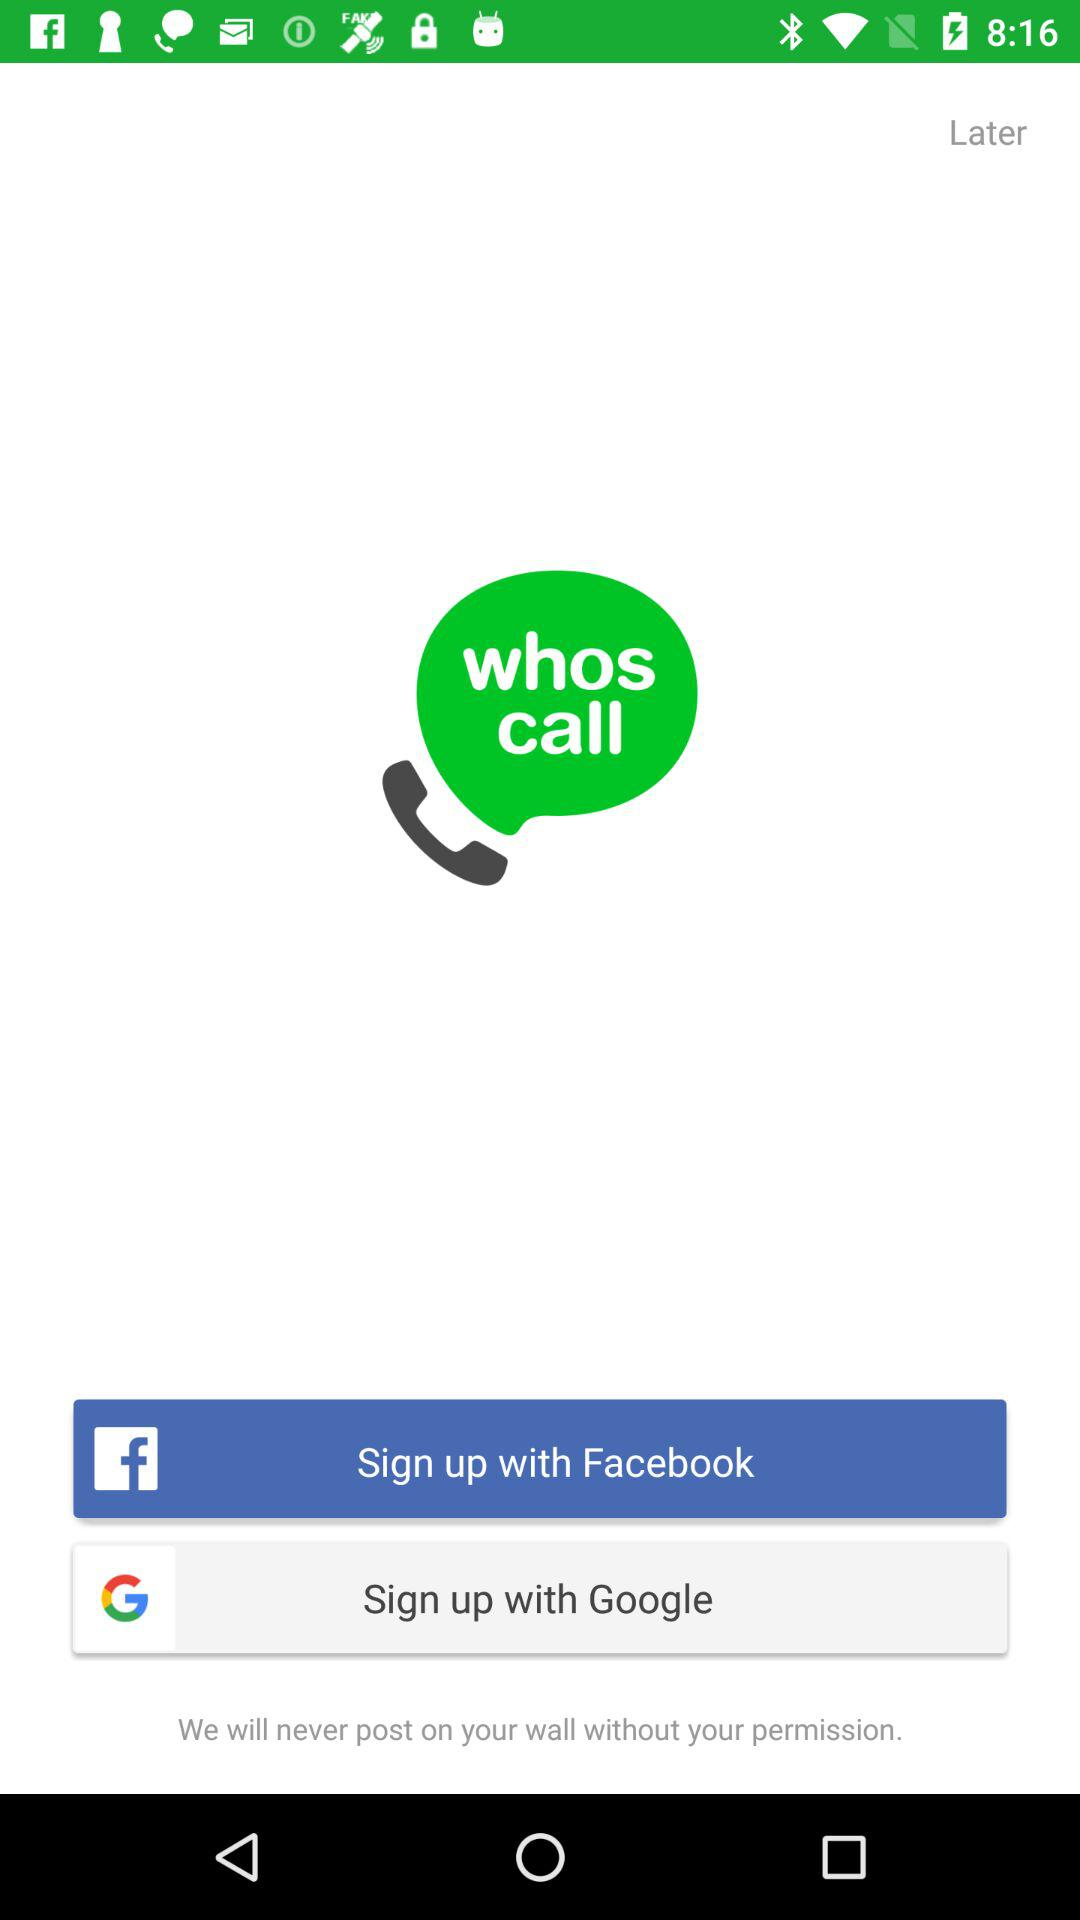Which options are given for signing up? The options for signing up are "Facebook" and "Google". 